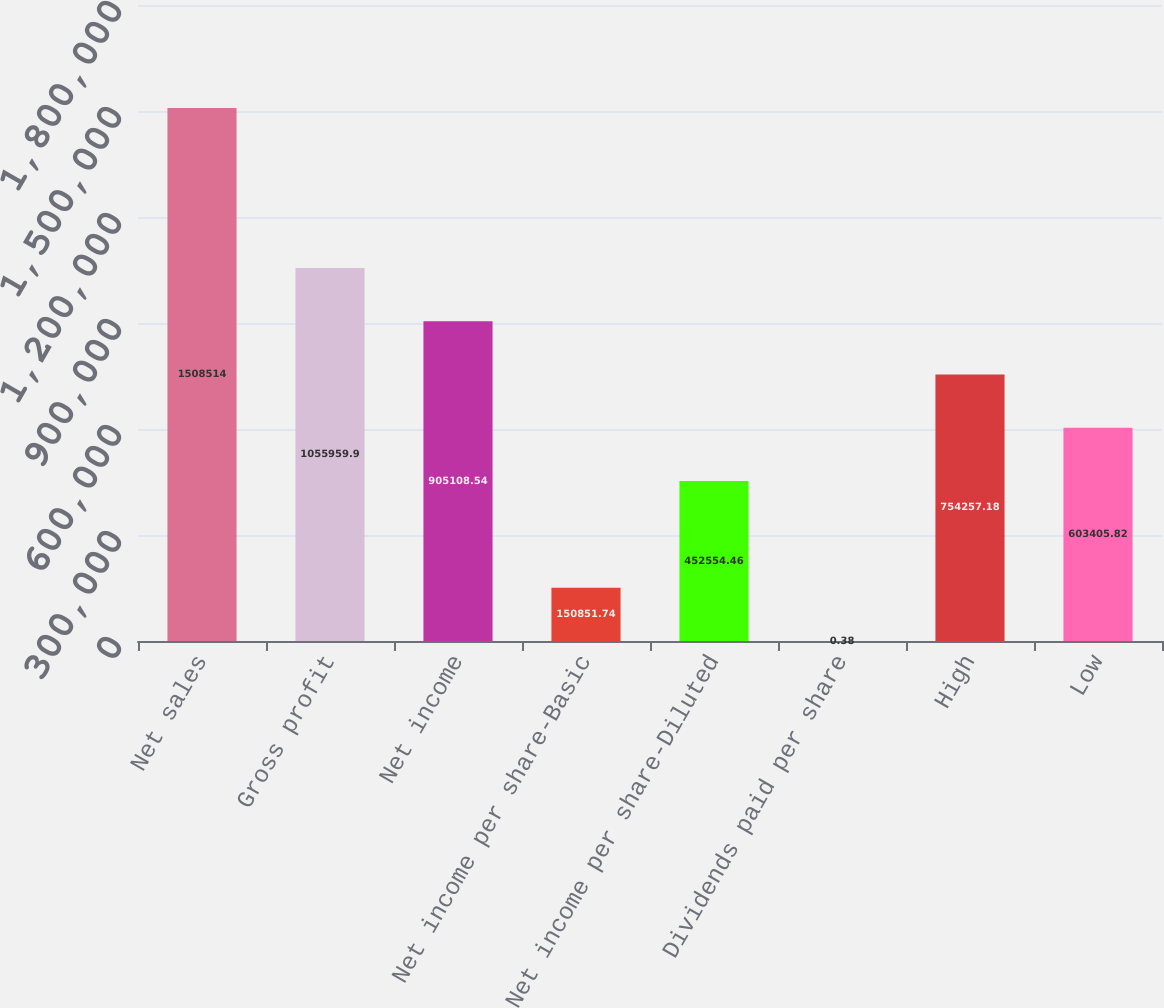Convert chart to OTSL. <chart><loc_0><loc_0><loc_500><loc_500><bar_chart><fcel>Net sales<fcel>Gross profit<fcel>Net income<fcel>Net income per share-Basic<fcel>Net income per share-Diluted<fcel>Dividends paid per share<fcel>High<fcel>Low<nl><fcel>1.50851e+06<fcel>1.05596e+06<fcel>905109<fcel>150852<fcel>452554<fcel>0.38<fcel>754257<fcel>603406<nl></chart> 